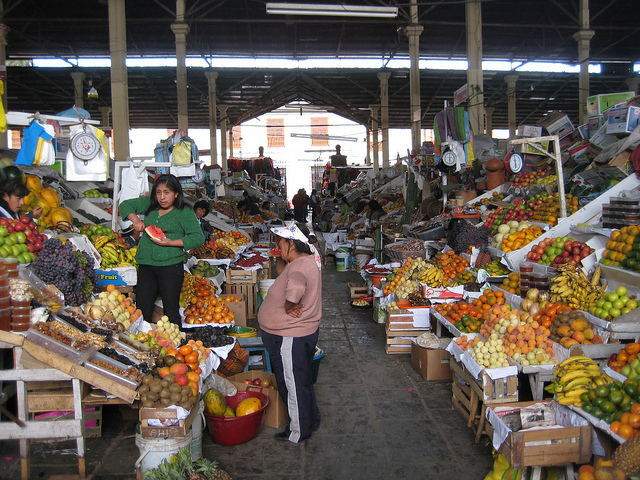Describe the atmosphere of the market. The market has a bustling atmosphere with vendors actively engaging with customers and displaying an abundance of produce. The array of fruits and goods, along with the visible interactions, suggests a vibrant and dynamic local marketplace. 